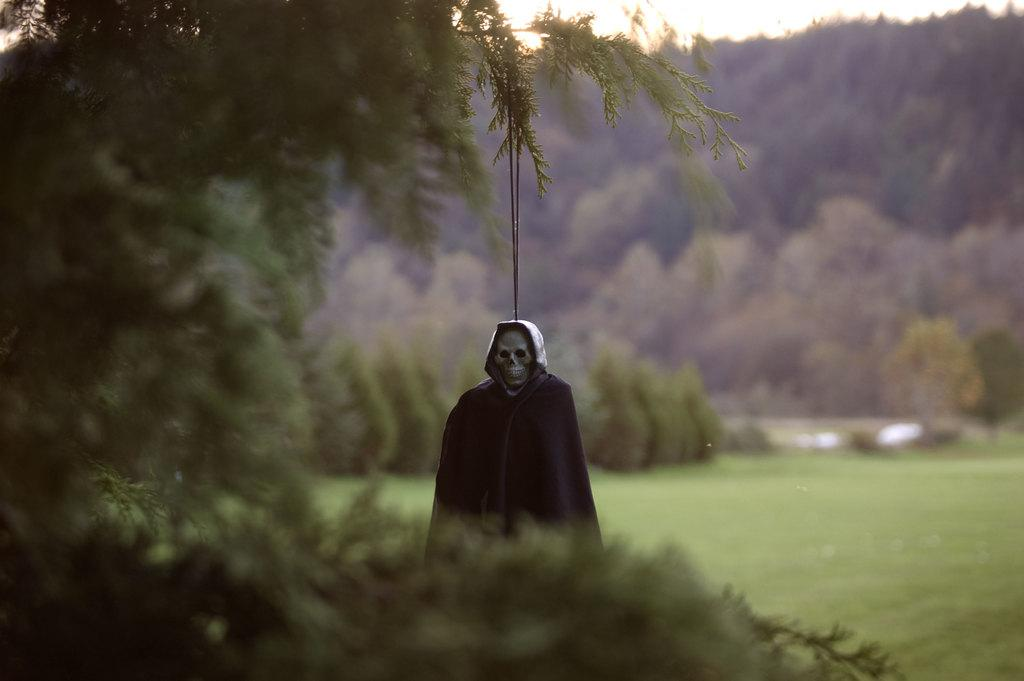What is the person in the image wearing on their face? The person is wearing a skeleton mask in the image. How is the person positioned in the image? The person is hanging from a tree. What type of vegetation is present on the ground in the image? There is grass on the surface at the back side of the image. What can be seen in the distance behind the person? There are trees and the sky visible in the background of the image. What type of glass object can be seen floating in the river in the image? There is no river or glass object present in the image. 